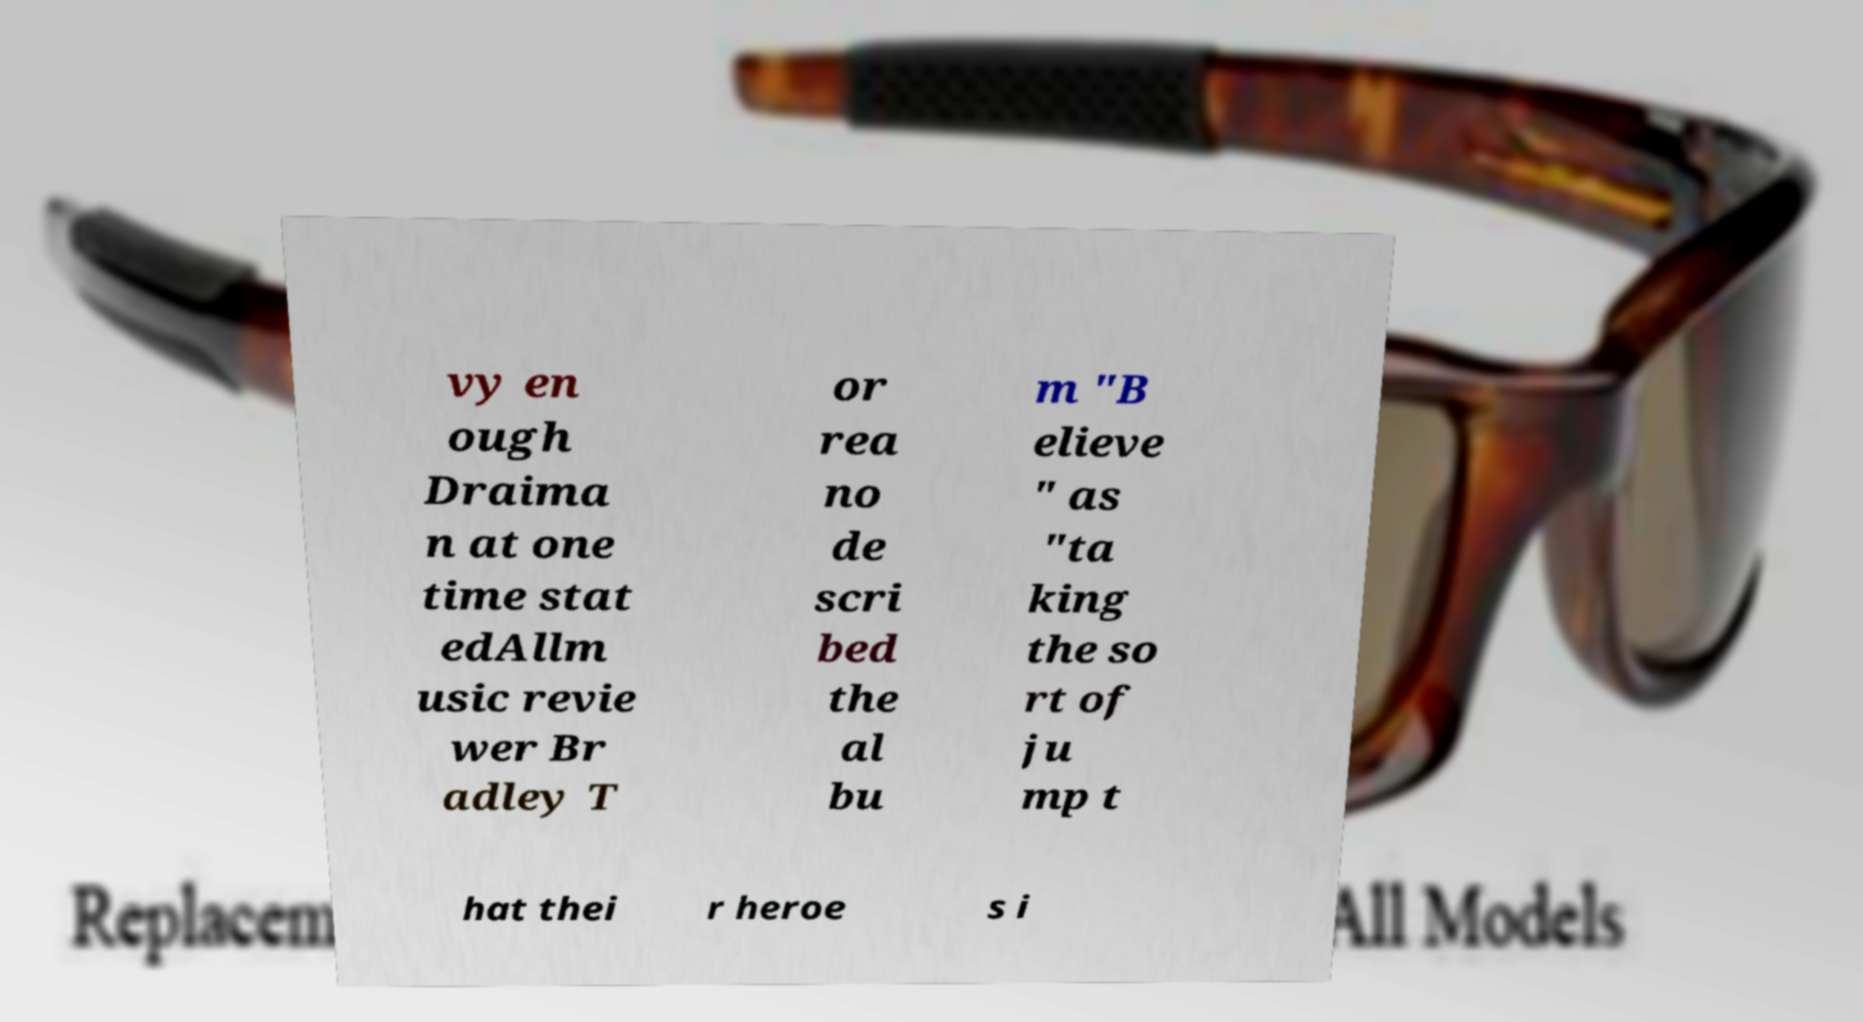I need the written content from this picture converted into text. Can you do that? vy en ough Draima n at one time stat edAllm usic revie wer Br adley T or rea no de scri bed the al bu m "B elieve " as "ta king the so rt of ju mp t hat thei r heroe s i 